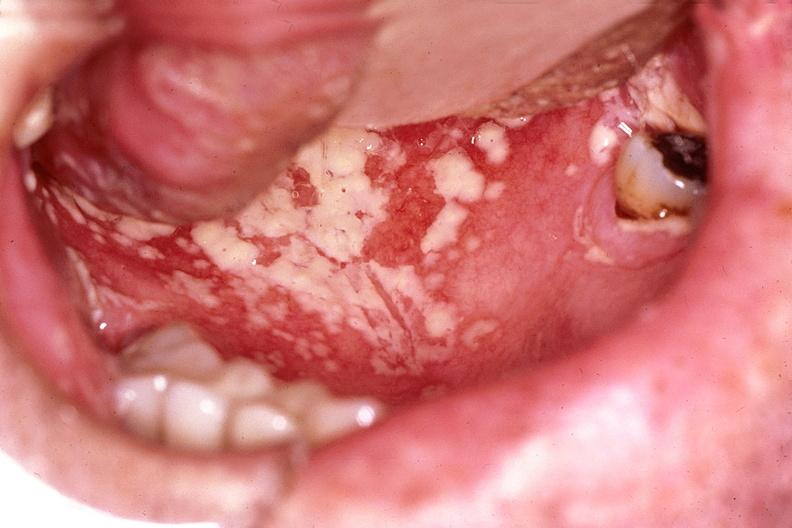does the excellent uterus show mouth, candida, thrush?
Answer the question using a single word or phrase. No 